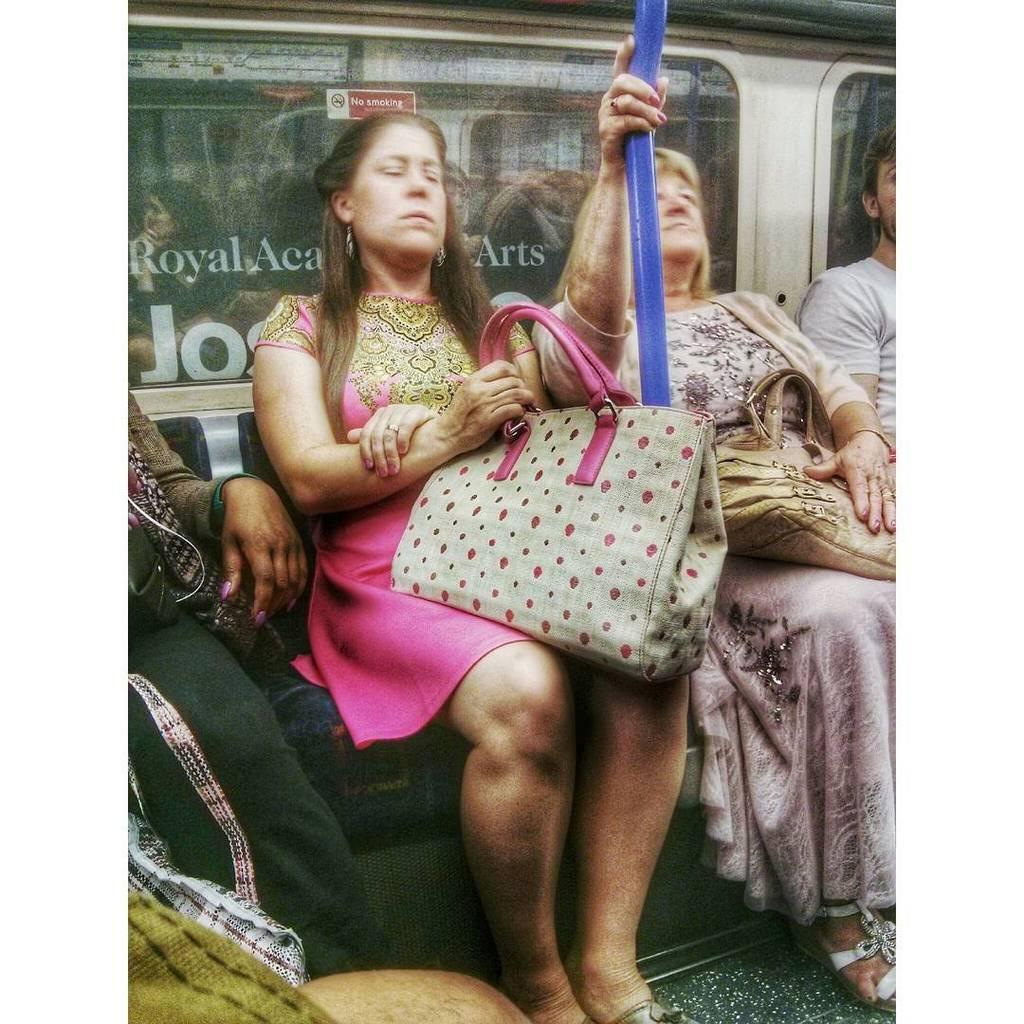What are the people in the image doing? The people in the image are sitting. What objects are some of the people holding? Some of the people are holding handbags. What type of sound can be heard coming from the crown in the image? There is no crown present in the image, so it is not possible to determine what sound might be heard. 